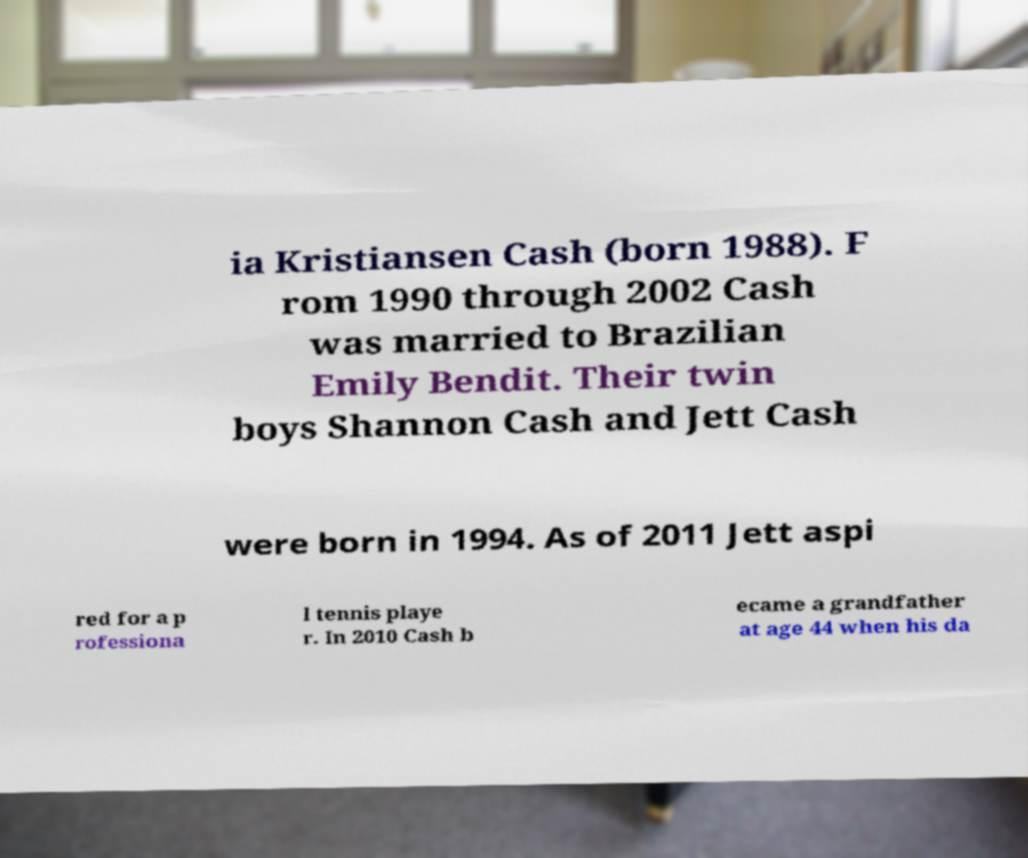Could you assist in decoding the text presented in this image and type it out clearly? ia Kristiansen Cash (born 1988). F rom 1990 through 2002 Cash was married to Brazilian Emily Bendit. Their twin boys Shannon Cash and Jett Cash were born in 1994. As of 2011 Jett aspi red for a p rofessiona l tennis playe r. In 2010 Cash b ecame a grandfather at age 44 when his da 